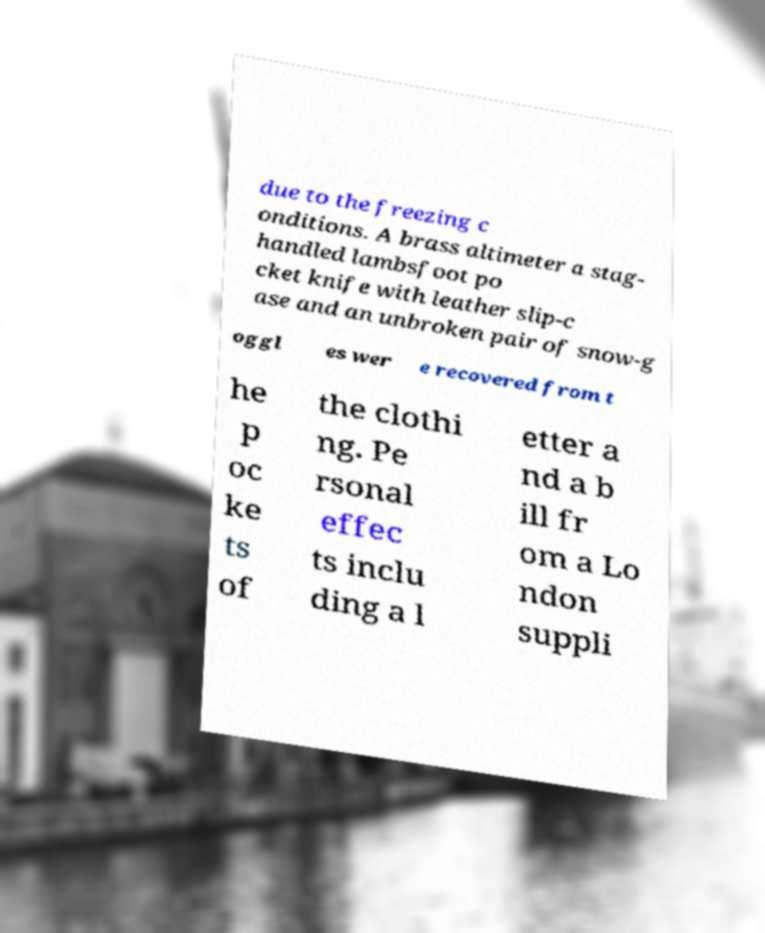Could you extract and type out the text from this image? due to the freezing c onditions. A brass altimeter a stag- handled lambsfoot po cket knife with leather slip-c ase and an unbroken pair of snow-g oggl es wer e recovered from t he p oc ke ts of the clothi ng. Pe rsonal effec ts inclu ding a l etter a nd a b ill fr om a Lo ndon suppli 